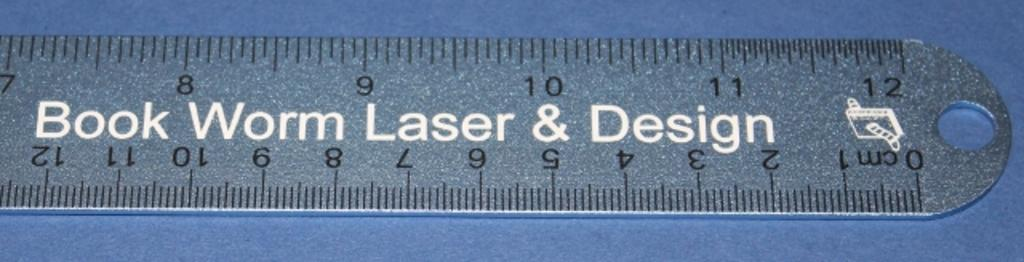Provide a one-sentence caption for the provided image. The last few inches of a ruler bear the name Book Work Laser & Design. 